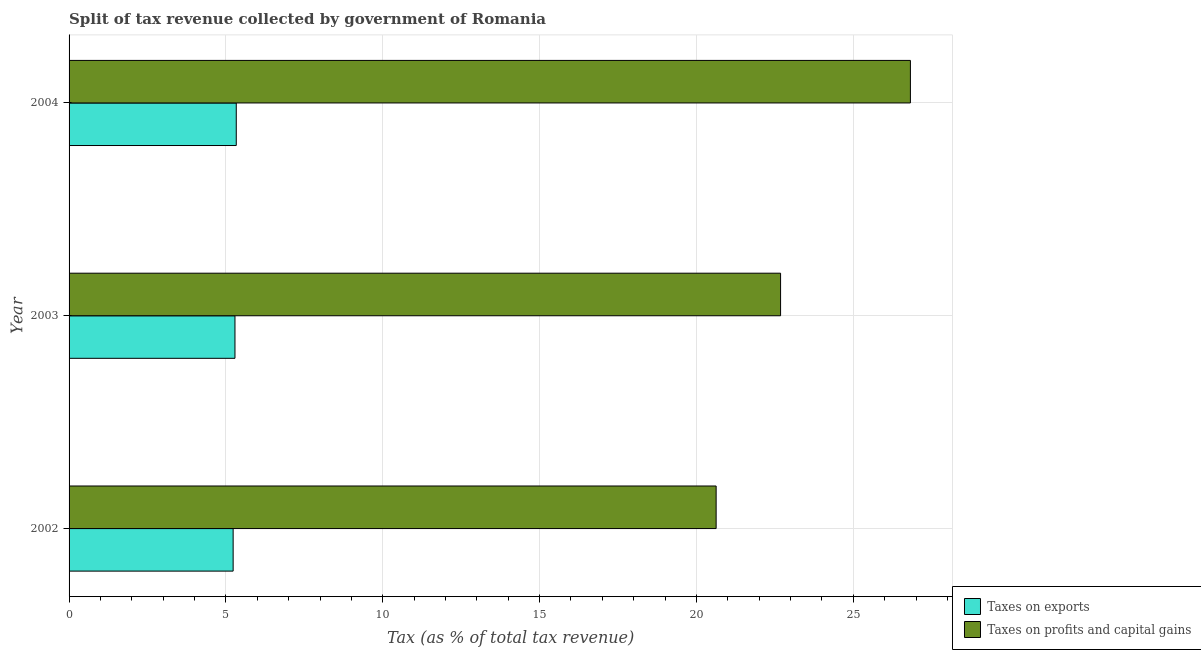How many different coloured bars are there?
Your answer should be very brief. 2. How many groups of bars are there?
Make the answer very short. 3. Are the number of bars per tick equal to the number of legend labels?
Offer a very short reply. Yes. Are the number of bars on each tick of the Y-axis equal?
Your answer should be very brief. Yes. How many bars are there on the 3rd tick from the bottom?
Your answer should be very brief. 2. In how many cases, is the number of bars for a given year not equal to the number of legend labels?
Your response must be concise. 0. What is the percentage of revenue obtained from taxes on exports in 2002?
Your answer should be very brief. 5.23. Across all years, what is the maximum percentage of revenue obtained from taxes on exports?
Provide a short and direct response. 5.33. Across all years, what is the minimum percentage of revenue obtained from taxes on profits and capital gains?
Provide a short and direct response. 20.63. In which year was the percentage of revenue obtained from taxes on exports maximum?
Your answer should be very brief. 2004. In which year was the percentage of revenue obtained from taxes on profits and capital gains minimum?
Ensure brevity in your answer.  2002. What is the total percentage of revenue obtained from taxes on exports in the graph?
Provide a succinct answer. 15.85. What is the difference between the percentage of revenue obtained from taxes on exports in 2002 and that in 2003?
Keep it short and to the point. -0.06. What is the difference between the percentage of revenue obtained from taxes on profits and capital gains in 2003 and the percentage of revenue obtained from taxes on exports in 2002?
Provide a short and direct response. 17.45. What is the average percentage of revenue obtained from taxes on profits and capital gains per year?
Your answer should be compact. 23.38. In the year 2002, what is the difference between the percentage of revenue obtained from taxes on profits and capital gains and percentage of revenue obtained from taxes on exports?
Make the answer very short. 15.4. In how many years, is the percentage of revenue obtained from taxes on profits and capital gains greater than 11 %?
Make the answer very short. 3. What is the ratio of the percentage of revenue obtained from taxes on exports in 2002 to that in 2004?
Your answer should be very brief. 0.98. Is the percentage of revenue obtained from taxes on profits and capital gains in 2003 less than that in 2004?
Your answer should be very brief. Yes. Is the difference between the percentage of revenue obtained from taxes on exports in 2003 and 2004 greater than the difference between the percentage of revenue obtained from taxes on profits and capital gains in 2003 and 2004?
Provide a succinct answer. Yes. What is the difference between the highest and the second highest percentage of revenue obtained from taxes on exports?
Your response must be concise. 0.04. What is the difference between the highest and the lowest percentage of revenue obtained from taxes on profits and capital gains?
Give a very brief answer. 6.19. In how many years, is the percentage of revenue obtained from taxes on profits and capital gains greater than the average percentage of revenue obtained from taxes on profits and capital gains taken over all years?
Your response must be concise. 1. What does the 1st bar from the top in 2004 represents?
Make the answer very short. Taxes on profits and capital gains. What does the 1st bar from the bottom in 2003 represents?
Offer a very short reply. Taxes on exports. Are all the bars in the graph horizontal?
Make the answer very short. Yes. How many years are there in the graph?
Your answer should be very brief. 3. What is the difference between two consecutive major ticks on the X-axis?
Offer a very short reply. 5. Are the values on the major ticks of X-axis written in scientific E-notation?
Keep it short and to the point. No. Does the graph contain any zero values?
Keep it short and to the point. No. Where does the legend appear in the graph?
Offer a very short reply. Bottom right. How many legend labels are there?
Offer a terse response. 2. What is the title of the graph?
Offer a very short reply. Split of tax revenue collected by government of Romania. Does "Frequency of shipment arrival" appear as one of the legend labels in the graph?
Offer a terse response. No. What is the label or title of the X-axis?
Provide a short and direct response. Tax (as % of total tax revenue). What is the Tax (as % of total tax revenue) of Taxes on exports in 2002?
Ensure brevity in your answer.  5.23. What is the Tax (as % of total tax revenue) in Taxes on profits and capital gains in 2002?
Your response must be concise. 20.63. What is the Tax (as % of total tax revenue) in Taxes on exports in 2003?
Offer a very short reply. 5.29. What is the Tax (as % of total tax revenue) of Taxes on profits and capital gains in 2003?
Provide a succinct answer. 22.68. What is the Tax (as % of total tax revenue) of Taxes on exports in 2004?
Offer a terse response. 5.33. What is the Tax (as % of total tax revenue) in Taxes on profits and capital gains in 2004?
Provide a succinct answer. 26.82. Across all years, what is the maximum Tax (as % of total tax revenue) of Taxes on exports?
Your response must be concise. 5.33. Across all years, what is the maximum Tax (as % of total tax revenue) of Taxes on profits and capital gains?
Ensure brevity in your answer.  26.82. Across all years, what is the minimum Tax (as % of total tax revenue) in Taxes on exports?
Keep it short and to the point. 5.23. Across all years, what is the minimum Tax (as % of total tax revenue) of Taxes on profits and capital gains?
Offer a terse response. 20.63. What is the total Tax (as % of total tax revenue) of Taxes on exports in the graph?
Make the answer very short. 15.85. What is the total Tax (as % of total tax revenue) of Taxes on profits and capital gains in the graph?
Your answer should be compact. 70.13. What is the difference between the Tax (as % of total tax revenue) in Taxes on exports in 2002 and that in 2003?
Offer a very short reply. -0.06. What is the difference between the Tax (as % of total tax revenue) of Taxes on profits and capital gains in 2002 and that in 2003?
Ensure brevity in your answer.  -2.05. What is the difference between the Tax (as % of total tax revenue) of Taxes on exports in 2002 and that in 2004?
Keep it short and to the point. -0.1. What is the difference between the Tax (as % of total tax revenue) of Taxes on profits and capital gains in 2002 and that in 2004?
Ensure brevity in your answer.  -6.19. What is the difference between the Tax (as % of total tax revenue) in Taxes on exports in 2003 and that in 2004?
Ensure brevity in your answer.  -0.04. What is the difference between the Tax (as % of total tax revenue) in Taxes on profits and capital gains in 2003 and that in 2004?
Offer a very short reply. -4.14. What is the difference between the Tax (as % of total tax revenue) of Taxes on exports in 2002 and the Tax (as % of total tax revenue) of Taxes on profits and capital gains in 2003?
Offer a very short reply. -17.45. What is the difference between the Tax (as % of total tax revenue) of Taxes on exports in 2002 and the Tax (as % of total tax revenue) of Taxes on profits and capital gains in 2004?
Ensure brevity in your answer.  -21.59. What is the difference between the Tax (as % of total tax revenue) in Taxes on exports in 2003 and the Tax (as % of total tax revenue) in Taxes on profits and capital gains in 2004?
Your answer should be compact. -21.53. What is the average Tax (as % of total tax revenue) in Taxes on exports per year?
Make the answer very short. 5.28. What is the average Tax (as % of total tax revenue) in Taxes on profits and capital gains per year?
Ensure brevity in your answer.  23.38. In the year 2002, what is the difference between the Tax (as % of total tax revenue) of Taxes on exports and Tax (as % of total tax revenue) of Taxes on profits and capital gains?
Provide a succinct answer. -15.4. In the year 2003, what is the difference between the Tax (as % of total tax revenue) in Taxes on exports and Tax (as % of total tax revenue) in Taxes on profits and capital gains?
Your answer should be very brief. -17.39. In the year 2004, what is the difference between the Tax (as % of total tax revenue) of Taxes on exports and Tax (as % of total tax revenue) of Taxes on profits and capital gains?
Ensure brevity in your answer.  -21.49. What is the ratio of the Tax (as % of total tax revenue) of Taxes on profits and capital gains in 2002 to that in 2003?
Keep it short and to the point. 0.91. What is the ratio of the Tax (as % of total tax revenue) of Taxes on exports in 2002 to that in 2004?
Your answer should be very brief. 0.98. What is the ratio of the Tax (as % of total tax revenue) in Taxes on profits and capital gains in 2002 to that in 2004?
Provide a succinct answer. 0.77. What is the ratio of the Tax (as % of total tax revenue) in Taxes on exports in 2003 to that in 2004?
Your response must be concise. 0.99. What is the ratio of the Tax (as % of total tax revenue) in Taxes on profits and capital gains in 2003 to that in 2004?
Give a very brief answer. 0.85. What is the difference between the highest and the second highest Tax (as % of total tax revenue) of Taxes on exports?
Provide a succinct answer. 0.04. What is the difference between the highest and the second highest Tax (as % of total tax revenue) in Taxes on profits and capital gains?
Provide a succinct answer. 4.14. What is the difference between the highest and the lowest Tax (as % of total tax revenue) in Taxes on exports?
Make the answer very short. 0.1. What is the difference between the highest and the lowest Tax (as % of total tax revenue) of Taxes on profits and capital gains?
Keep it short and to the point. 6.19. 